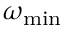Convert formula to latex. <formula><loc_0><loc_0><loc_500><loc_500>\omega _ { \min }</formula> 